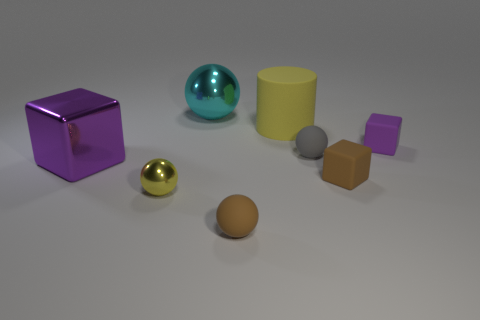Can you describe the colors and shapes visible in the scene? Certainly! The image features a variety of geometric shapes with different colors and finishes. On the left, there's a reflective purple metallic cube and a small shiny gold sphere. In the center, we see a large teal sphere with a glossy finish and a matte yellow cylinder. Towards the right, there's a small grey matte sphere, a tiny purple cube, and a brown matte sphere. Overall, the scene is a collection of simple 3D shapes with a diverse array of colors and textures. 